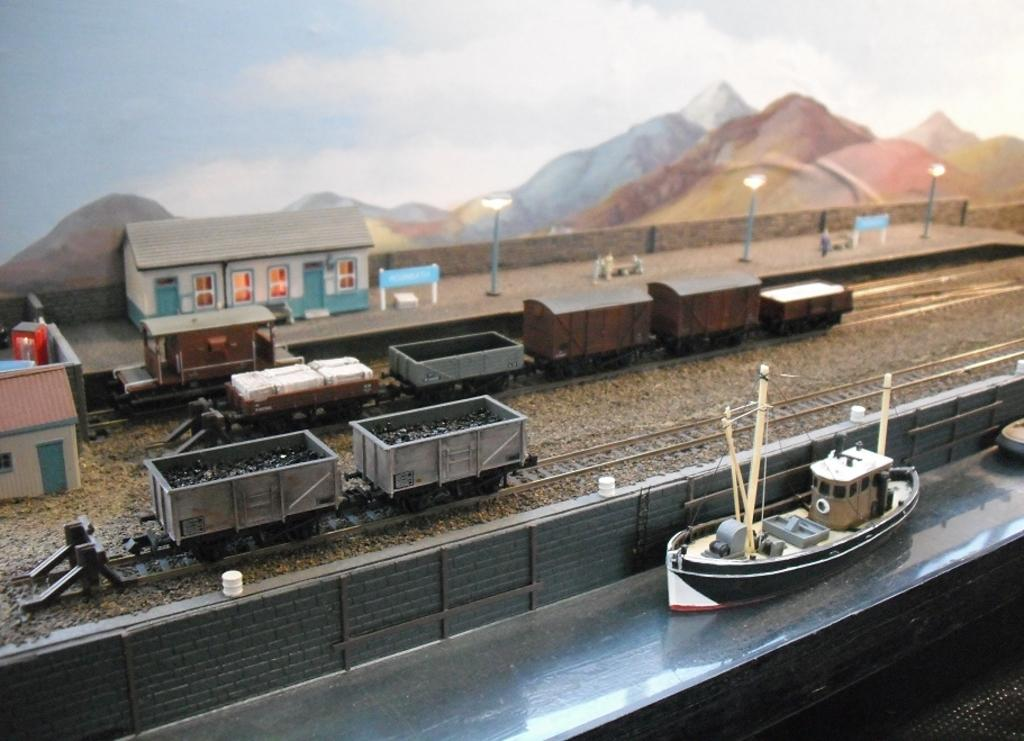What type of vehicles can be seen in the image? There are ship, train, and house toys in the image, which represent different types of vehicles. What other toys are present in the image besides vehicles? There are railway track, hill, and pole toys in the image. What is the setting of the toys in the image? The toys are placed on the ground, which is visible in the image, and there is a fence in the image as well. What can be seen in the background of the image? The sky is visible in the image, and there are some objects on the ground. What type of vase can be seen in the image? There is no vase present in the image; it features various toys and a fence. 